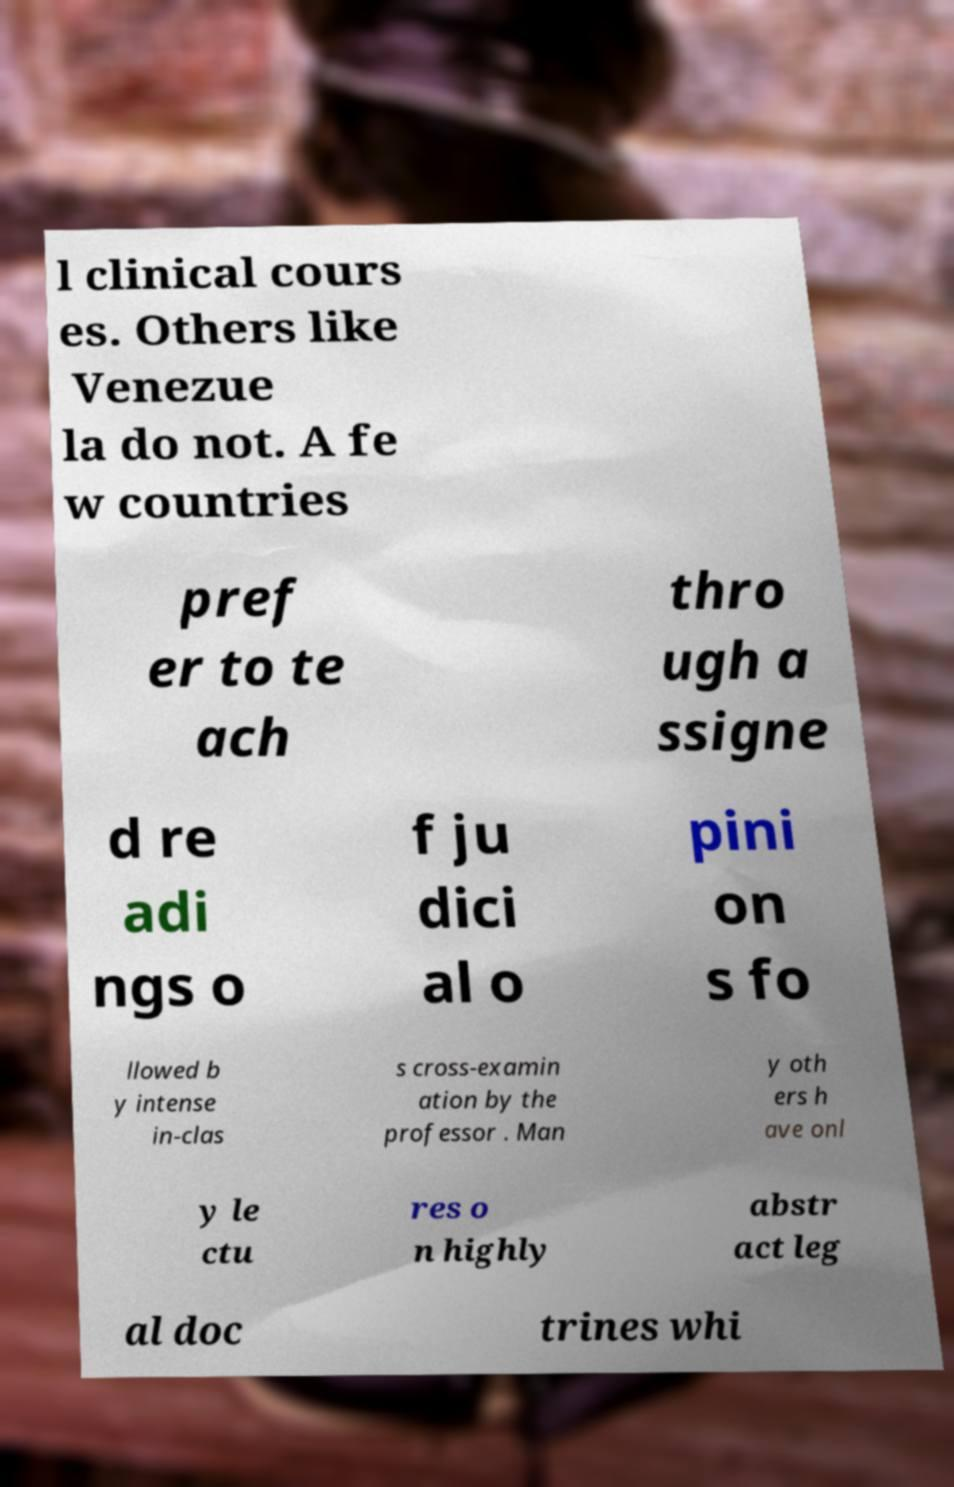Could you assist in decoding the text presented in this image and type it out clearly? l clinical cours es. Others like Venezue la do not. A fe w countries pref er to te ach thro ugh a ssigne d re adi ngs o f ju dici al o pini on s fo llowed b y intense in-clas s cross-examin ation by the professor . Man y oth ers h ave onl y le ctu res o n highly abstr act leg al doc trines whi 